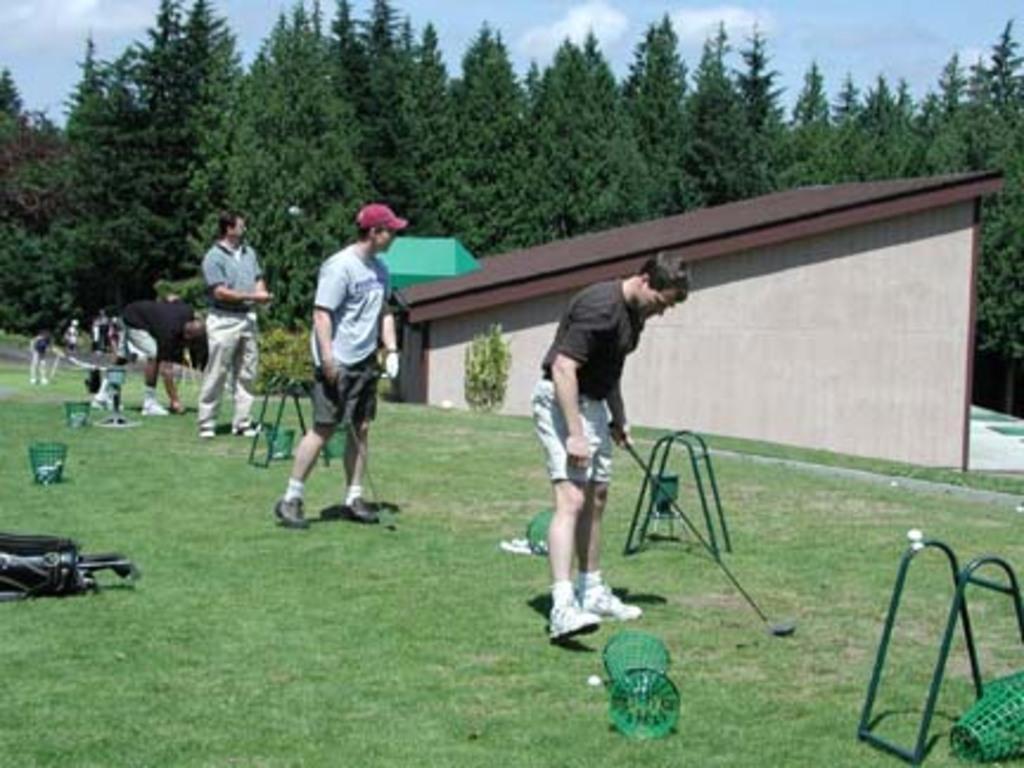How would you summarize this image in a sentence or two? In this image there are persons standing and in the background there are trees. In the front there is a stand which is green in colour on the right side, and there's grass on the ground. 